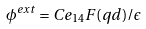<formula> <loc_0><loc_0><loc_500><loc_500>\phi ^ { e x t } = C e _ { 1 4 } F ( q d ) / \epsilon</formula> 